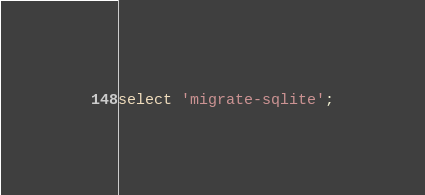Convert code to text. <code><loc_0><loc_0><loc_500><loc_500><_SQL_>select 'migrate-sqlite';
</code> 